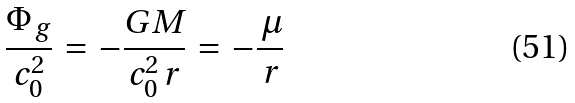<formula> <loc_0><loc_0><loc_500><loc_500>\frac { \Phi _ { \, g } } { c _ { 0 } ^ { 2 } } \, = \, - \frac { G M } { c _ { 0 } ^ { 2 } \, r } \, = \, - \frac { \, \mu } { \, r }</formula> 